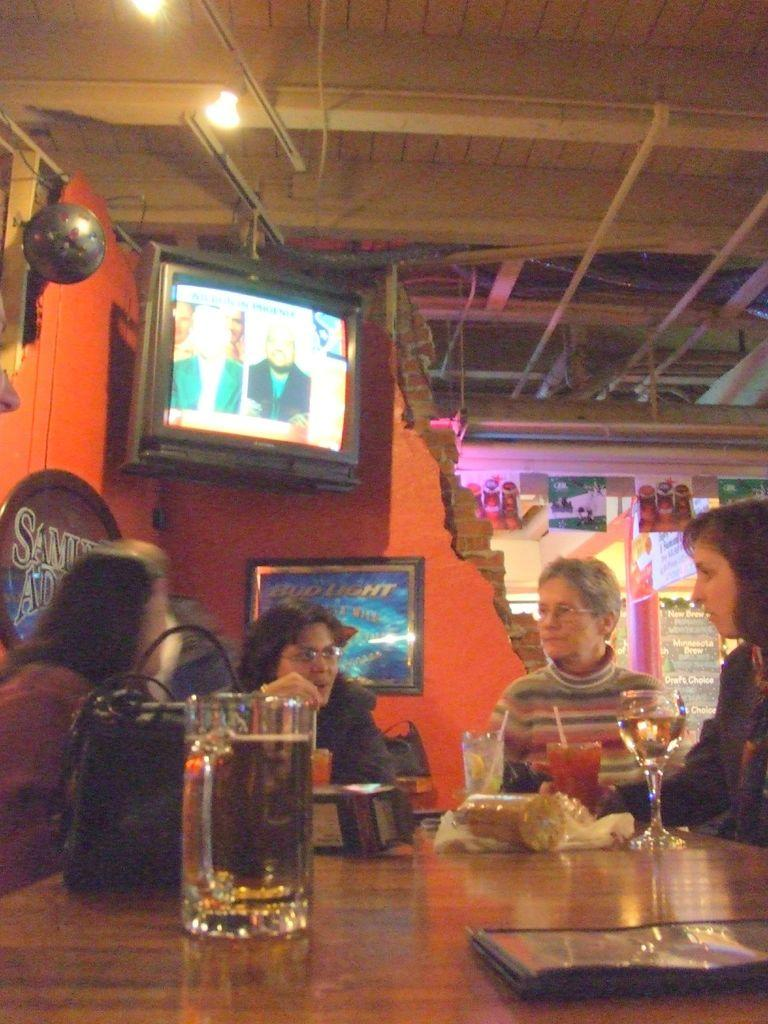How many people are present in the image? There are four people in the image. What objects can be seen on the table? There is a cup, a glass, and a bag on the table. What is the board used for in the image? The purpose of the board in the image is not specified, but it is present. What electronic device is visible in the image? There is a television in the image. What type of light is present in the image? There is a light in the image. What title is given to the stick that the people are using in the image? There is no stick present in the image, and therefore no title can be given. 